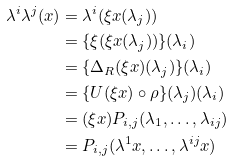<formula> <loc_0><loc_0><loc_500><loc_500>\lambda ^ { i } \lambda ^ { j } ( x ) & = \lambda ^ { i } ( \xi x ( \lambda _ { j } ) ) \\ & = \{ \xi ( \xi x ( \lambda _ { j } ) ) \} ( \lambda _ { i } ) \\ & = \{ \Delta _ { R } ( \xi x ) ( \lambda _ { j } ) \} ( \lambda _ { i } ) \\ & = \{ U ( \xi x ) \circ \rho \} ( \lambda _ { j } ) ( \lambda _ { i } ) \\ & = ( \xi x ) P _ { i , j } ( \lambda _ { 1 } , \dots , \lambda _ { i j } ) \\ & = P _ { i , j } ( \lambda ^ { 1 } x , \dots , \lambda ^ { i j } x )</formula> 